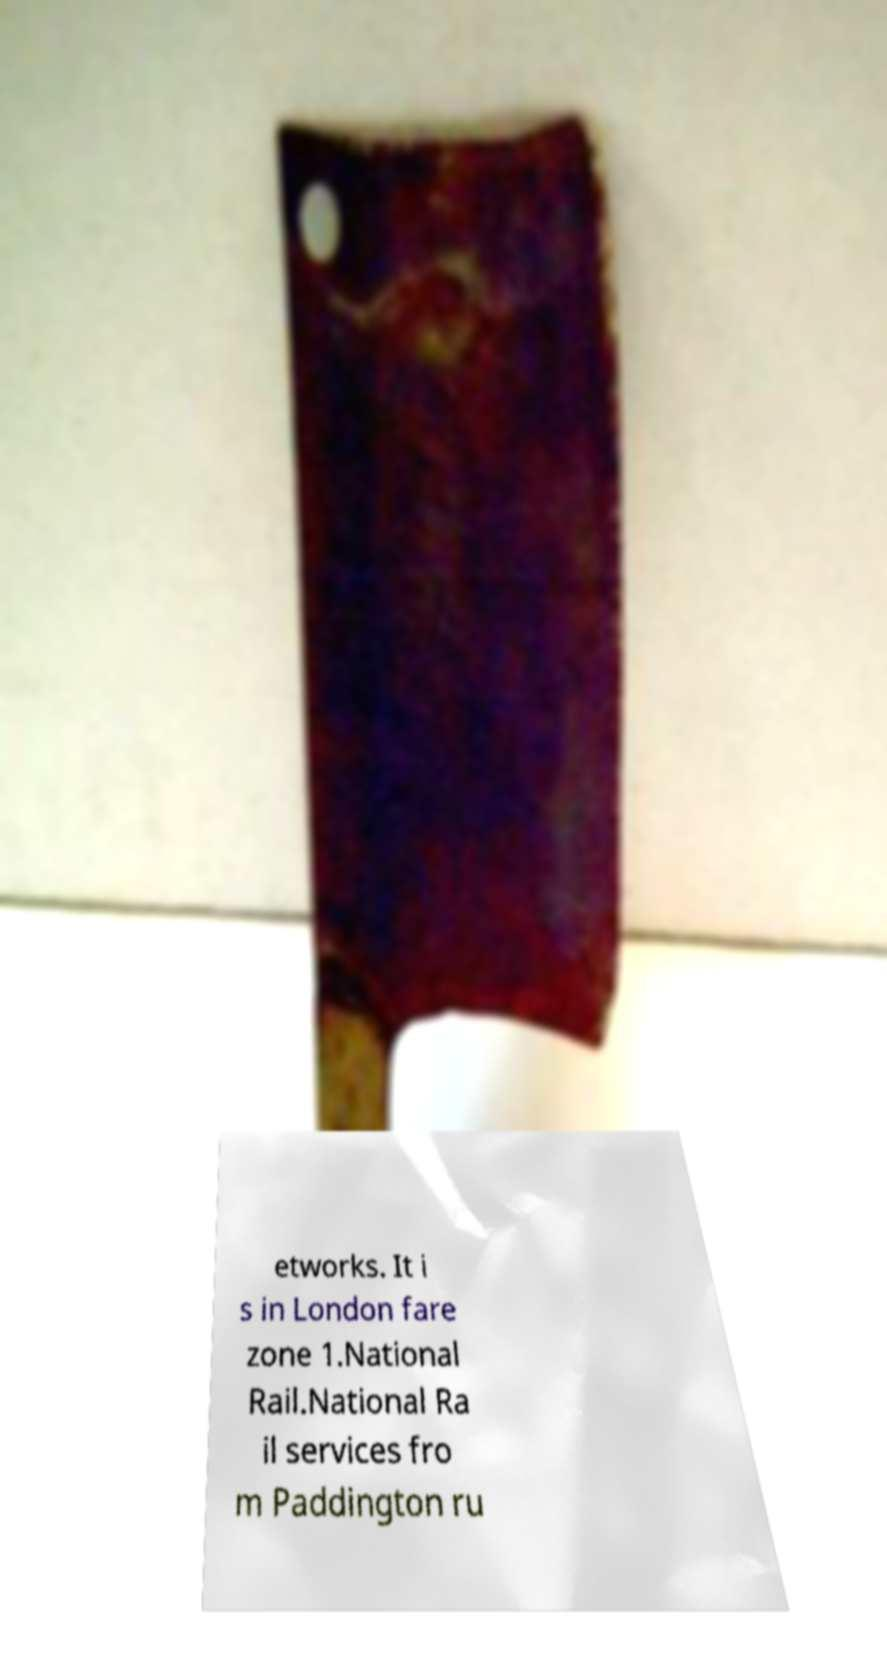I need the written content from this picture converted into text. Can you do that? etworks. It i s in London fare zone 1.National Rail.National Ra il services fro m Paddington ru 